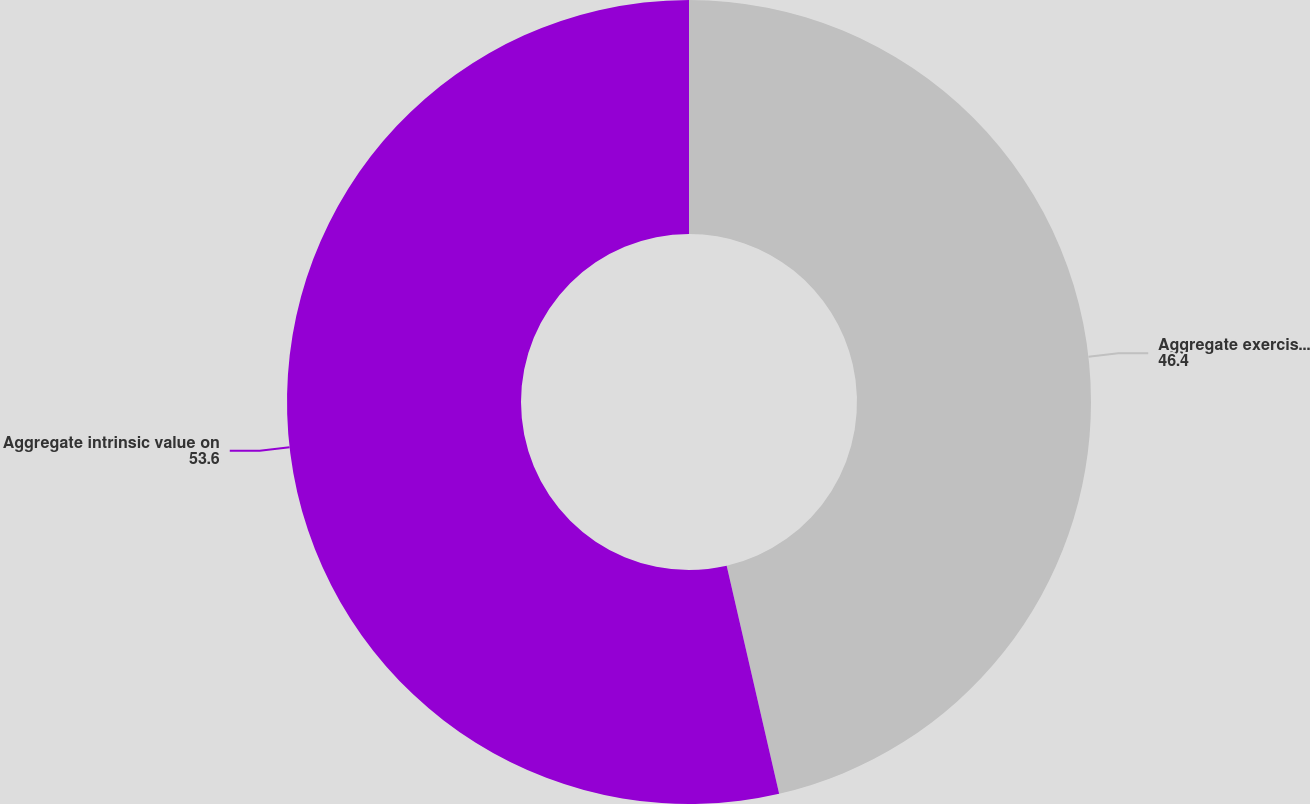Convert chart to OTSL. <chart><loc_0><loc_0><loc_500><loc_500><pie_chart><fcel>Aggregate exercise proceeds<fcel>Aggregate intrinsic value on<nl><fcel>46.4%<fcel>53.6%<nl></chart> 